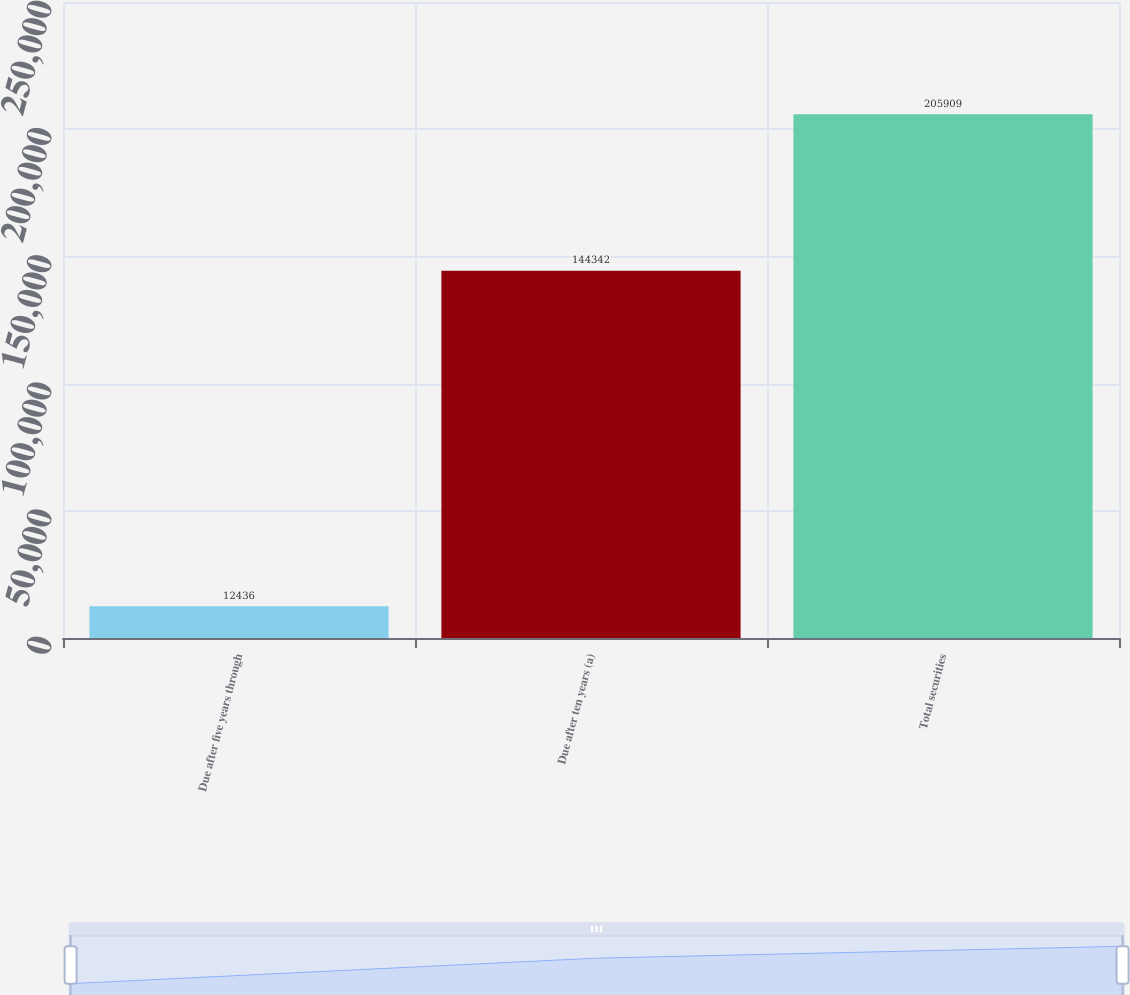<chart> <loc_0><loc_0><loc_500><loc_500><bar_chart><fcel>Due after five years through<fcel>Due after ten years (a)<fcel>Total securities<nl><fcel>12436<fcel>144342<fcel>205909<nl></chart> 